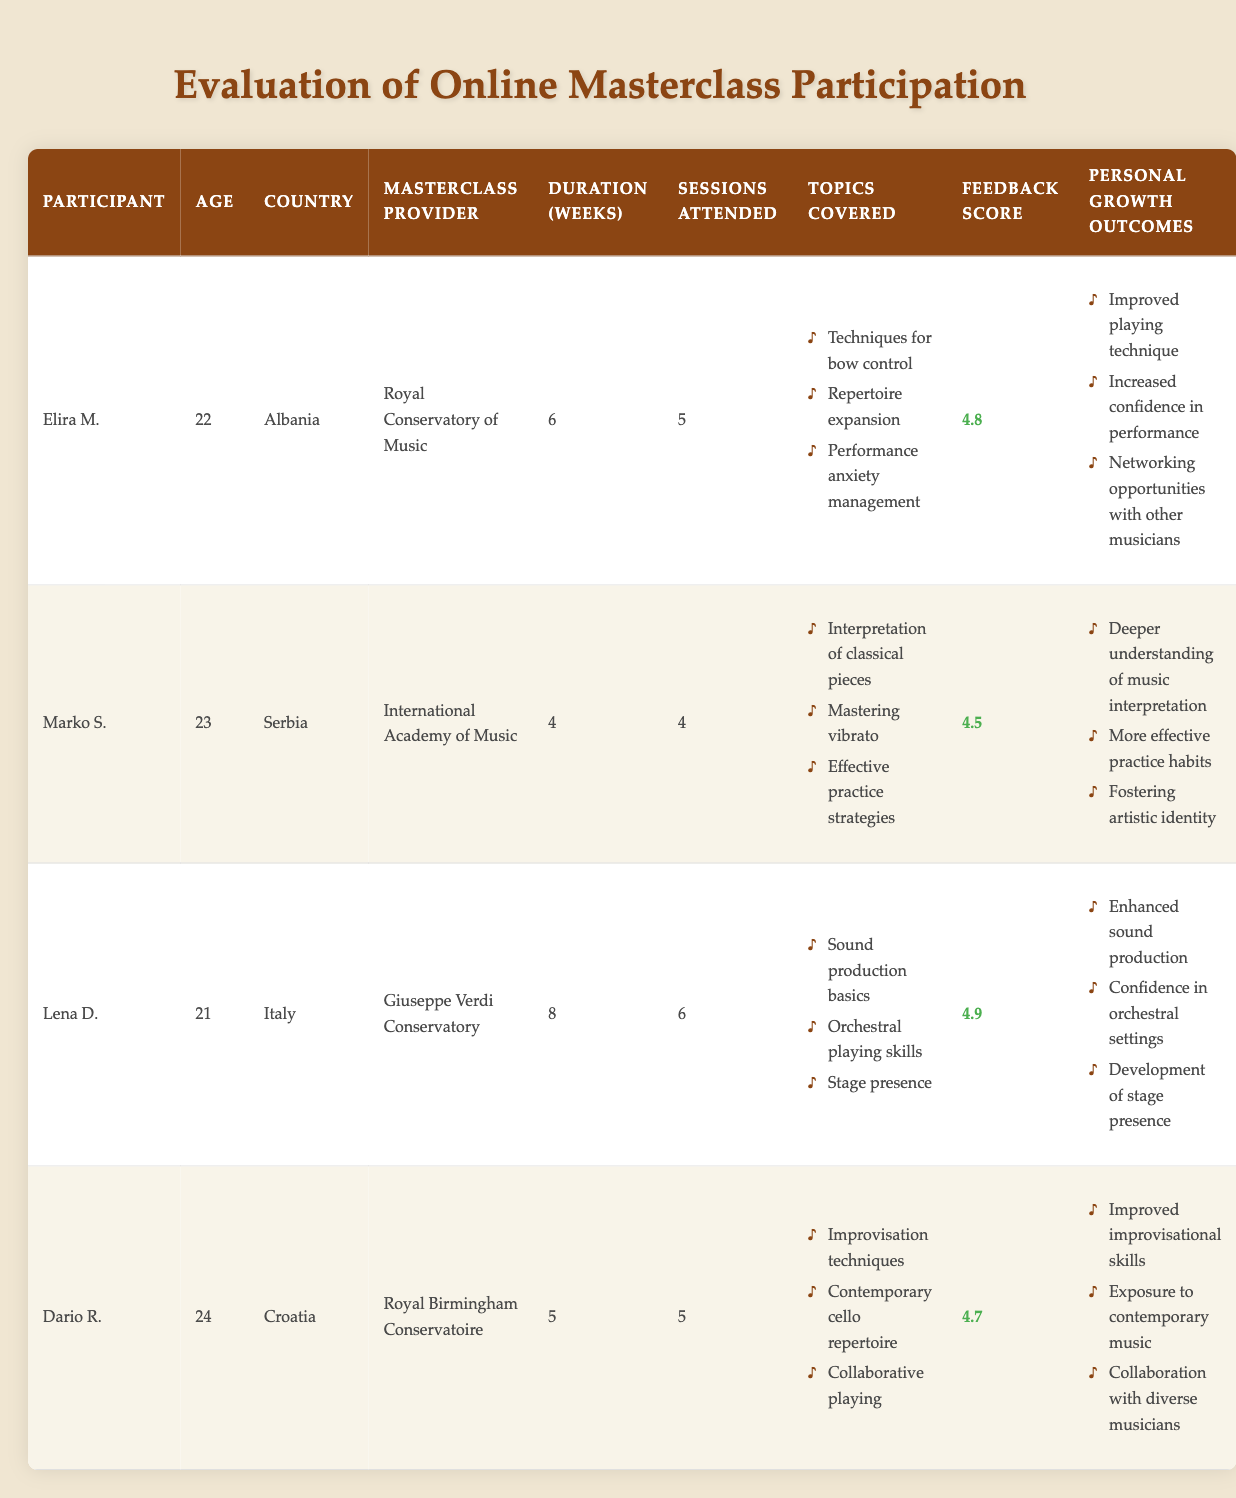What is the highest feedback score among the participants? The feedback scores for the participants are as follows: Elira M. (4.8), Marko S. (4.5), Lena D. (4.9), and Dario R. (4.7). The highest score is 4.9 from Lena D.
Answer: 4.9 How many sessions did Marko S. attend? According to the table, Marko S. attended 4 sessions.
Answer: 4 Which participant had the longest duration in weeks for their masterclass? The durations in weeks for each participant are: Elira M. (6), Marko S. (4), Lena D. (8), and Dario R. (5). Lena D. had the longest duration of 8 weeks.
Answer: Lena D Did Dario R. cover any topics related to improvisation techniques? Yes, Dario R. covered "Improvisation techniques" in his masterclass as mentioned in the topics covered.
Answer: Yes What is the average age of the participants in the table? To find the average age, sum the ages: 22 (Elira M.) + 23 (Marko S.) + 21 (Lena D.) + 24 (Dario R.) = 90. There are 4 participants, so the average age is 90 / 4 = 22.5.
Answer: 22.5 Which personal growth outcome was shared by Elira M. and Dario R.? Elira M.'s outcomes are improved playing technique, increased confidence in performance, and networking opportunities, while Dario R.'s outcomes are improved improvisational skills, exposure to contemporary music, and collaboration with diverse musicians. Neither shared an outcome; thus, there is none.
Answer: No shared outcome What feedback score corresponds to the participant from Croatia? The participant from Croatia is Dario R., who has a feedback score of 4.7 as indicated in the table.
Answer: 4.7 Which participant improved their stage presence? Lena D. had a personal growth outcome of "Development of stage presence" as stated in her outcomes.
Answer: Lena D 